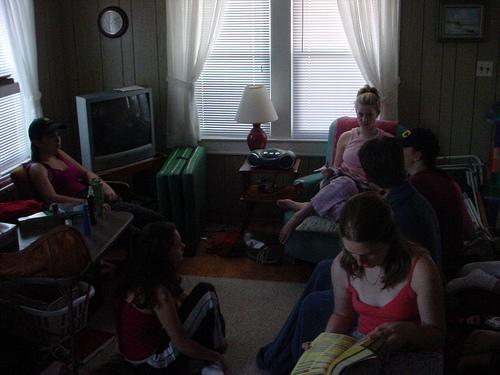What kind of pants is the girl in pink wearing? Please explain your reasoning. pajama bottoms. The pants are pa bottoms. 